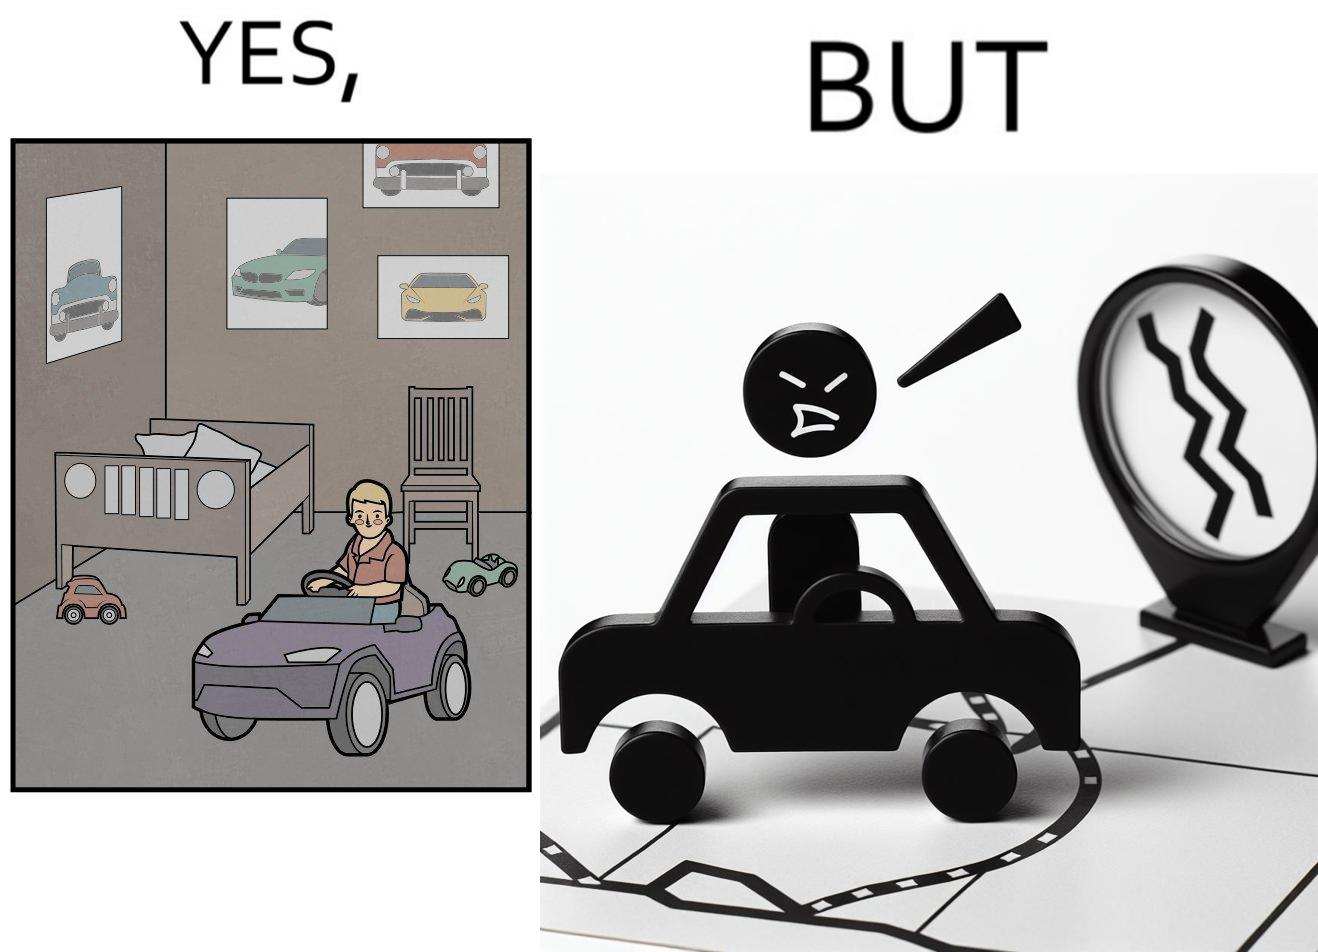Describe the satirical element in this image. The image is funny beaucse while the person as a child enjoyed being around cars, had various small toy cars and even rode a bigger toy car, as as grown up he does not enjoy being in a car during a traffic jam while he is driving . 